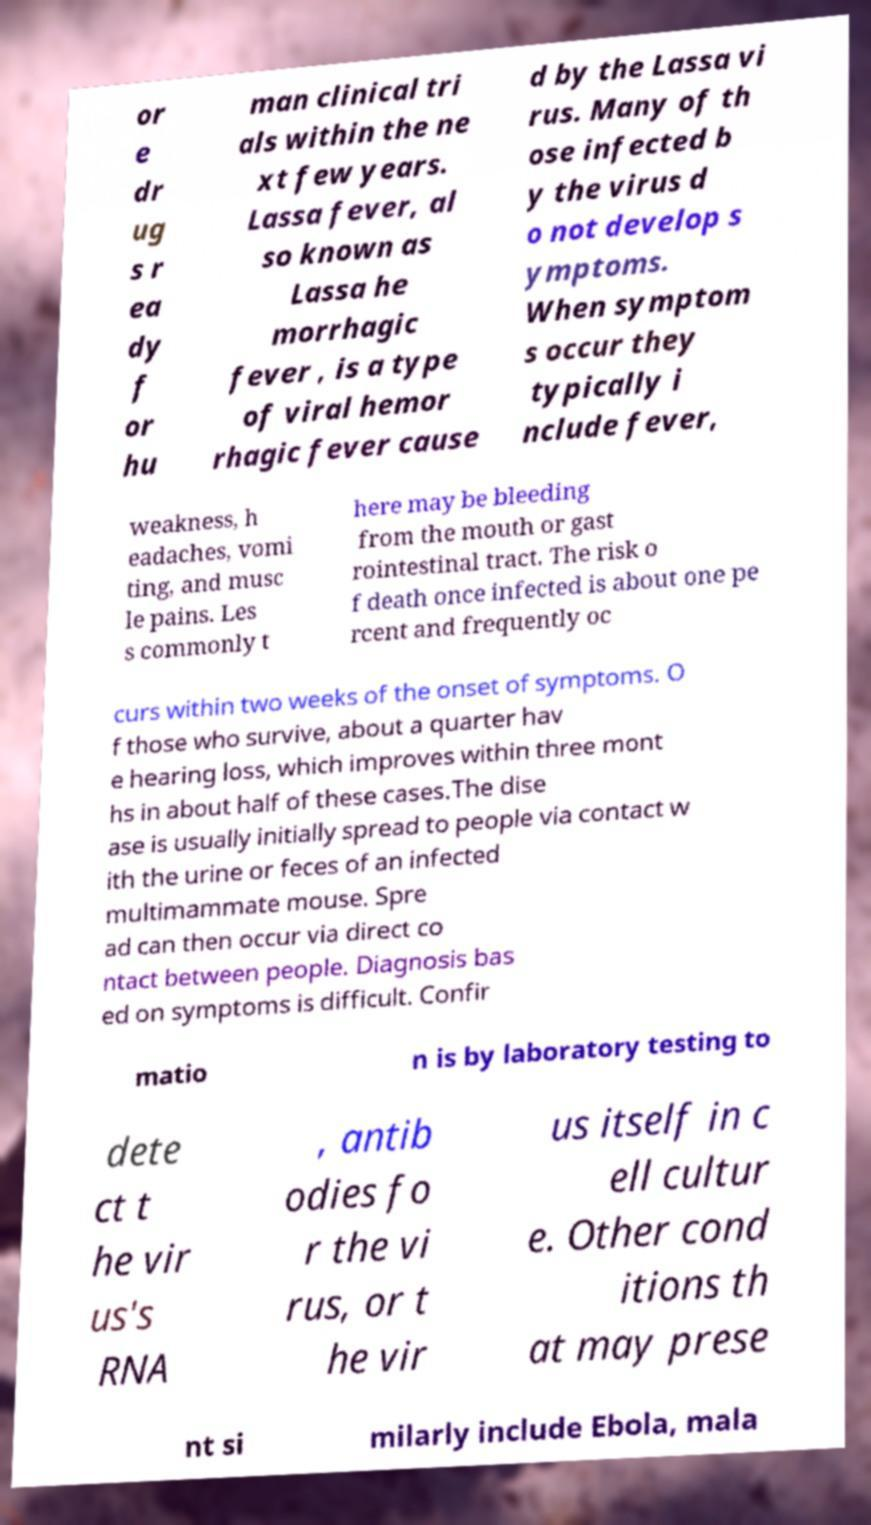Can you read and provide the text displayed in the image?This photo seems to have some interesting text. Can you extract and type it out for me? or e dr ug s r ea dy f or hu man clinical tri als within the ne xt few years. Lassa fever, al so known as Lassa he morrhagic fever , is a type of viral hemor rhagic fever cause d by the Lassa vi rus. Many of th ose infected b y the virus d o not develop s ymptoms. When symptom s occur they typically i nclude fever, weakness, h eadaches, vomi ting, and musc le pains. Les s commonly t here may be bleeding from the mouth or gast rointestinal tract. The risk o f death once infected is about one pe rcent and frequently oc curs within two weeks of the onset of symptoms. O f those who survive, about a quarter hav e hearing loss, which improves within three mont hs in about half of these cases.The dise ase is usually initially spread to people via contact w ith the urine or feces of an infected multimammate mouse. Spre ad can then occur via direct co ntact between people. Diagnosis bas ed on symptoms is difficult. Confir matio n is by laboratory testing to dete ct t he vir us's RNA , antib odies fo r the vi rus, or t he vir us itself in c ell cultur e. Other cond itions th at may prese nt si milarly include Ebola, mala 